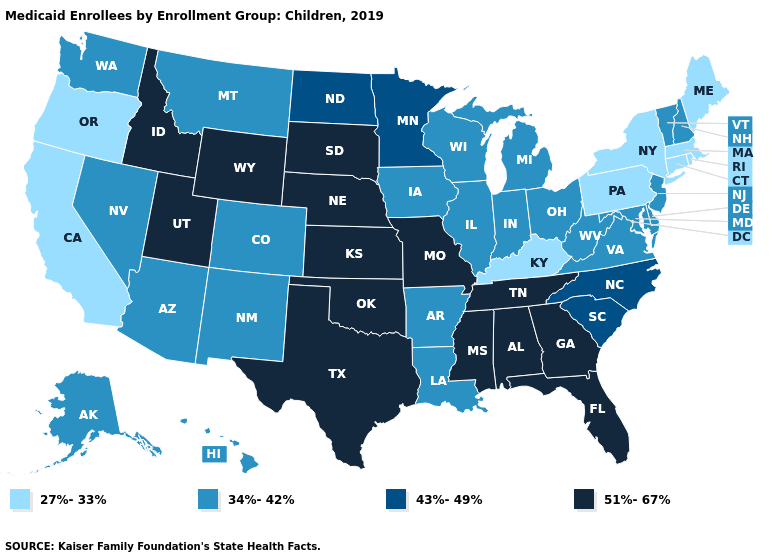What is the value of Idaho?
Be succinct. 51%-67%. What is the value of Minnesota?
Be succinct. 43%-49%. Name the states that have a value in the range 43%-49%?
Give a very brief answer. Minnesota, North Carolina, North Dakota, South Carolina. Name the states that have a value in the range 43%-49%?
Concise answer only. Minnesota, North Carolina, North Dakota, South Carolina. Among the states that border Massachusetts , which have the lowest value?
Give a very brief answer. Connecticut, New York, Rhode Island. Does Wisconsin have a higher value than Oklahoma?
Answer briefly. No. Among the states that border North Dakota , which have the highest value?
Short answer required. South Dakota. Name the states that have a value in the range 51%-67%?
Short answer required. Alabama, Florida, Georgia, Idaho, Kansas, Mississippi, Missouri, Nebraska, Oklahoma, South Dakota, Tennessee, Texas, Utah, Wyoming. Does the first symbol in the legend represent the smallest category?
Give a very brief answer. Yes. Does Vermont have the highest value in the Northeast?
Answer briefly. Yes. Name the states that have a value in the range 34%-42%?
Be succinct. Alaska, Arizona, Arkansas, Colorado, Delaware, Hawaii, Illinois, Indiana, Iowa, Louisiana, Maryland, Michigan, Montana, Nevada, New Hampshire, New Jersey, New Mexico, Ohio, Vermont, Virginia, Washington, West Virginia, Wisconsin. Name the states that have a value in the range 51%-67%?
Be succinct. Alabama, Florida, Georgia, Idaho, Kansas, Mississippi, Missouri, Nebraska, Oklahoma, South Dakota, Tennessee, Texas, Utah, Wyoming. Does Iowa have the same value as Oklahoma?
Give a very brief answer. No. Among the states that border North Carolina , which have the highest value?
Give a very brief answer. Georgia, Tennessee. 